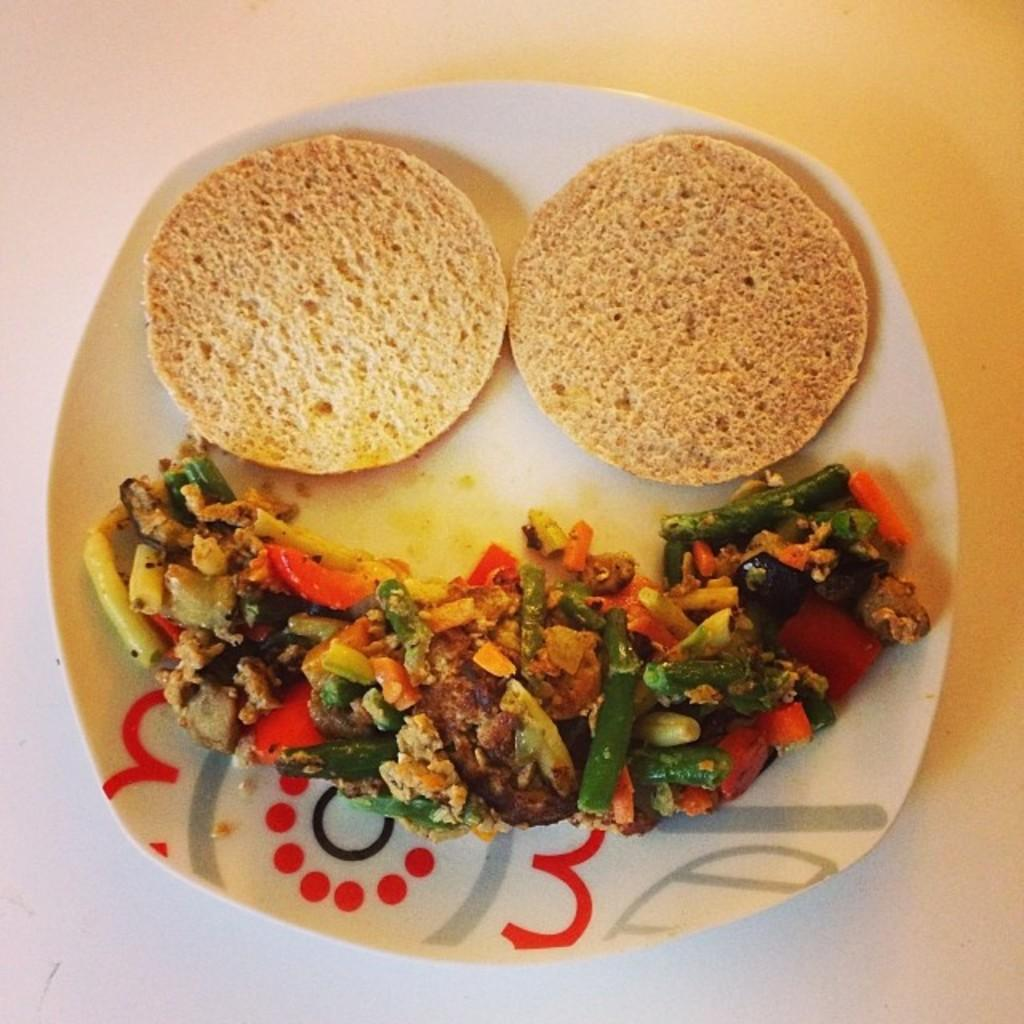What color is the plate that is visible in the image? The plate in the image is white. What is on the plate in the image? There are food items on the plate in the image. What type of disease is depicted on the plate in the image? There is no disease depicted on the plate in the image; it contains food items. Can you describe the person who is eating the food on the plate in the image? There is no person present in the image; it only shows a white color plate with food items on it. 